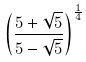Convert formula to latex. <formula><loc_0><loc_0><loc_500><loc_500>\left ( \frac { 5 + \sqrt { 5 } } { 5 - \sqrt { 5 } } \right ) ^ { \frac { 1 } { 4 } }</formula> 